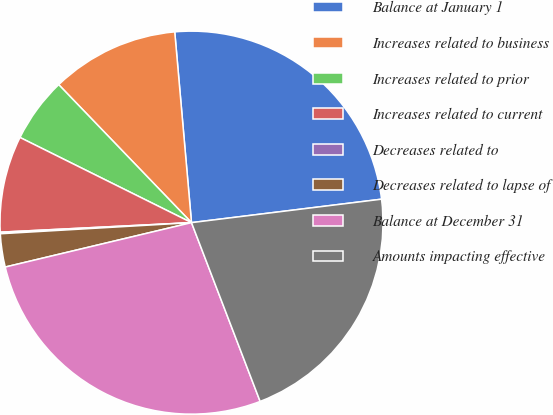Convert chart to OTSL. <chart><loc_0><loc_0><loc_500><loc_500><pie_chart><fcel>Balance at January 1<fcel>Increases related to business<fcel>Increases related to prior<fcel>Increases related to current<fcel>Decreases related to<fcel>Decreases related to lapse of<fcel>Balance at December 31<fcel>Amounts impacting effective<nl><fcel>24.44%<fcel>10.8%<fcel>5.47%<fcel>8.13%<fcel>0.13%<fcel>2.8%<fcel>27.11%<fcel>21.12%<nl></chart> 